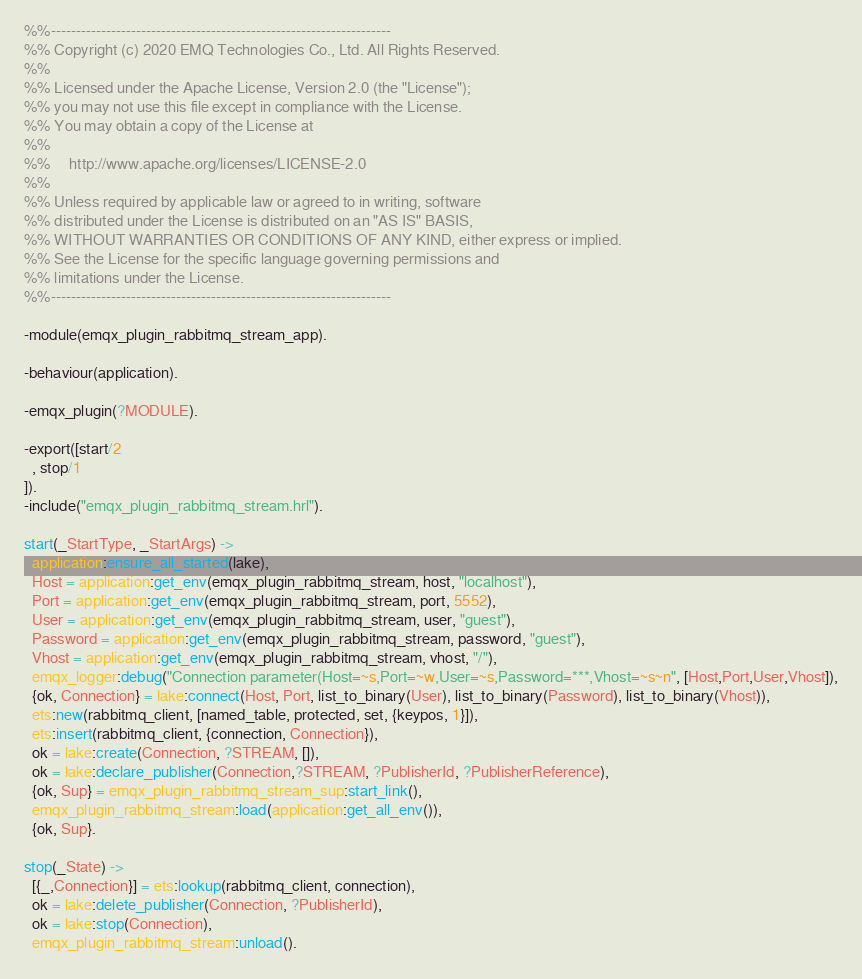<code> <loc_0><loc_0><loc_500><loc_500><_Erlang_>%%--------------------------------------------------------------------
%% Copyright (c) 2020 EMQ Technologies Co., Ltd. All Rights Reserved.
%%
%% Licensed under the Apache License, Version 2.0 (the "License");
%% you may not use this file except in compliance with the License.
%% You may obtain a copy of the License at
%%
%%     http://www.apache.org/licenses/LICENSE-2.0
%%
%% Unless required by applicable law or agreed to in writing, software
%% distributed under the License is distributed on an "AS IS" BASIS,
%% WITHOUT WARRANTIES OR CONDITIONS OF ANY KIND, either express or implied.
%% See the License for the specific language governing permissions and
%% limitations under the License.
%%--------------------------------------------------------------------

-module(emqx_plugin_rabbitmq_stream_app).

-behaviour(application).

-emqx_plugin(?MODULE).

-export([start/2
  , stop/1
]).
-include("emqx_plugin_rabbitmq_stream.hrl").

start(_StartType, _StartArgs) ->
  application:ensure_all_started(lake),
  Host = application:get_env(emqx_plugin_rabbitmq_stream, host, "localhost"),
  Port = application:get_env(emqx_plugin_rabbitmq_stream, port, 5552),
  User = application:get_env(emqx_plugin_rabbitmq_stream, user, "guest"),
  Password = application:get_env(emqx_plugin_rabbitmq_stream, password, "guest"),
  Vhost = application:get_env(emqx_plugin_rabbitmq_stream, vhost, "/"),
  emqx_logger:debug("Connection parameter(Host=~s,Port=~w,User=~s,Password=***,Vhost=~s~n", [Host,Port,User,Vhost]),
  {ok, Connection} = lake:connect(Host, Port, list_to_binary(User), list_to_binary(Password), list_to_binary(Vhost)),
  ets:new(rabbitmq_client, [named_table, protected, set, {keypos, 1}]),
  ets:insert(rabbitmq_client, {connection, Connection}),
  ok = lake:create(Connection, ?STREAM, []),
  ok = lake:declare_publisher(Connection,?STREAM, ?PublisherId, ?PublisherReference),
  {ok, Sup} = emqx_plugin_rabbitmq_stream_sup:start_link(),
  emqx_plugin_rabbitmq_stream:load(application:get_all_env()),
  {ok, Sup}.

stop(_State) ->
  [{_,Connection}] = ets:lookup(rabbitmq_client, connection),
  ok = lake:delete_publisher(Connection, ?PublisherId),
  ok = lake:stop(Connection),
  emqx_plugin_rabbitmq_stream:unload().

</code> 